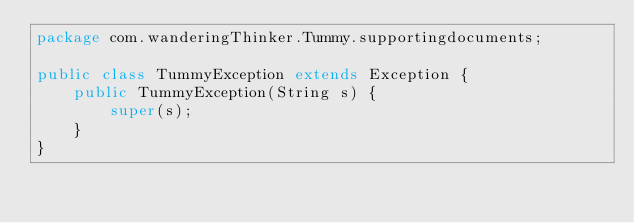<code> <loc_0><loc_0><loc_500><loc_500><_Java_>package com.wanderingThinker.Tummy.supportingdocuments;

public class TummyException extends Exception {
    public TummyException(String s) {
        super(s);
    }
}
</code> 